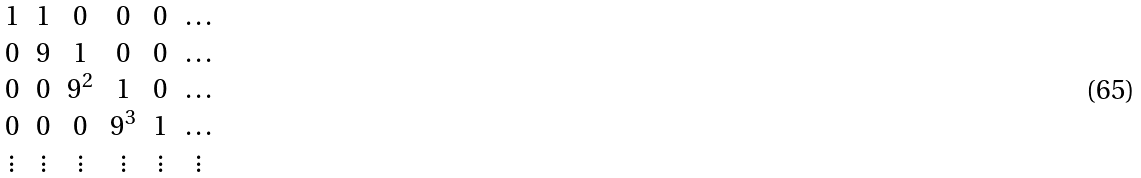Convert formula to latex. <formula><loc_0><loc_0><loc_500><loc_500>\begin{matrix} 1 & 1 & 0 & 0 & 0 & \dots \\ 0 & 9 & 1 & 0 & 0 & \dots \\ 0 & 0 & 9 ^ { 2 } & 1 & 0 & \dots \\ 0 & 0 & 0 & 9 ^ { 3 } & 1 & \dots \\ \vdots & \vdots & \vdots & \vdots & \vdots & \vdots \end{matrix}</formula> 